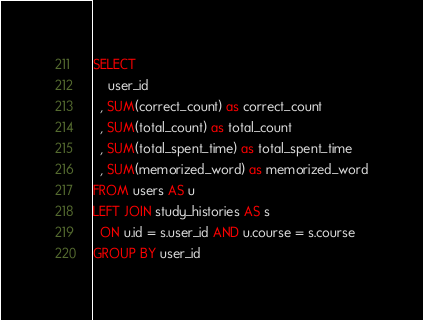Convert code to text. <code><loc_0><loc_0><loc_500><loc_500><_SQL_>SELECT
    user_id
  , SUM(correct_count) as correct_count
  , SUM(total_count) as total_count
  , SUM(total_spent_time) as total_spent_time
  , SUM(memorized_word) as memorized_word
FROM users AS u
LEFT JOIN study_histories AS s
  ON u.id = s.user_id AND u.course = s.course
GROUP BY user_id
</code> 